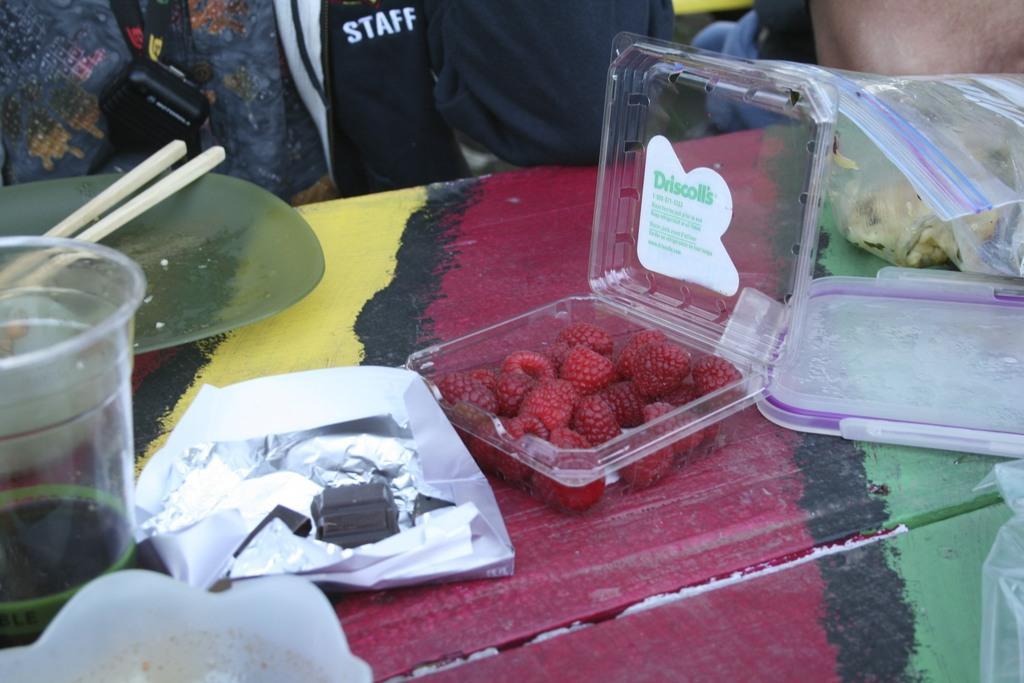Describe this image in one or two sentences. In this picture there is a opened box of strawberry, which is placed at the center of the image, there is a glass at the left side of the image and there is a lid of the box at the right side of the image. 